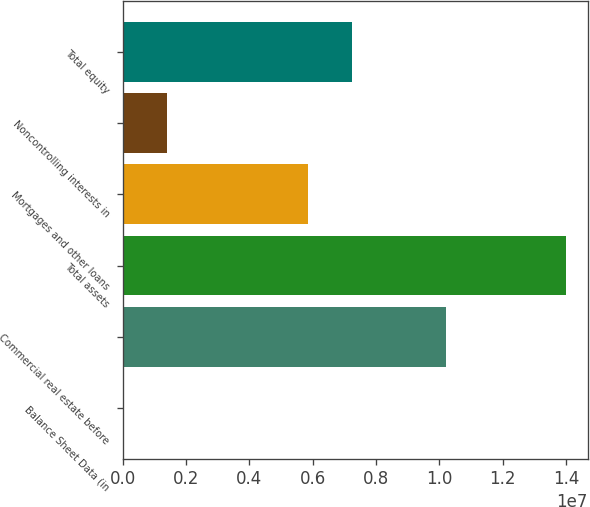Convert chart to OTSL. <chart><loc_0><loc_0><loc_500><loc_500><bar_chart><fcel>Balance Sheet Data (in<fcel>Commercial real estate before<fcel>Total assets<fcel>Mortgages and other loans<fcel>Noncontrolling interests in<fcel>Total equity<nl><fcel>2017<fcel>1.02061e+07<fcel>1.39829e+07<fcel>5.85513e+06<fcel>1.40011e+06<fcel>7.25322e+06<nl></chart> 